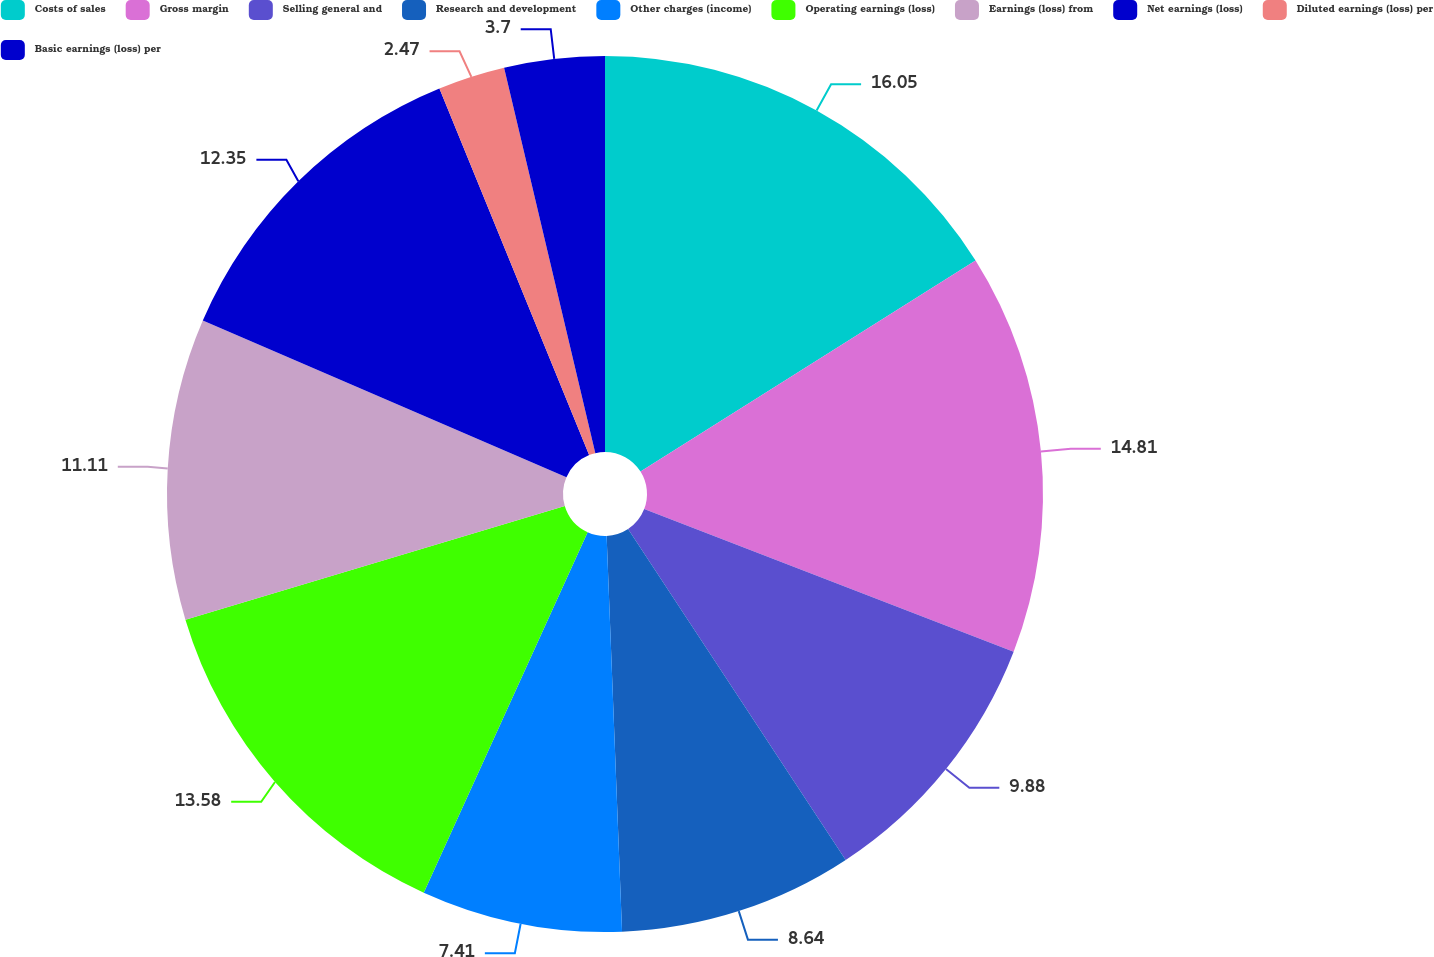Convert chart. <chart><loc_0><loc_0><loc_500><loc_500><pie_chart><fcel>Costs of sales<fcel>Gross margin<fcel>Selling general and<fcel>Research and development<fcel>Other charges (income)<fcel>Operating earnings (loss)<fcel>Earnings (loss) from<fcel>Net earnings (loss)<fcel>Diluted earnings (loss) per<fcel>Basic earnings (loss) per<nl><fcel>16.05%<fcel>14.81%<fcel>9.88%<fcel>8.64%<fcel>7.41%<fcel>13.58%<fcel>11.11%<fcel>12.35%<fcel>2.47%<fcel>3.7%<nl></chart> 